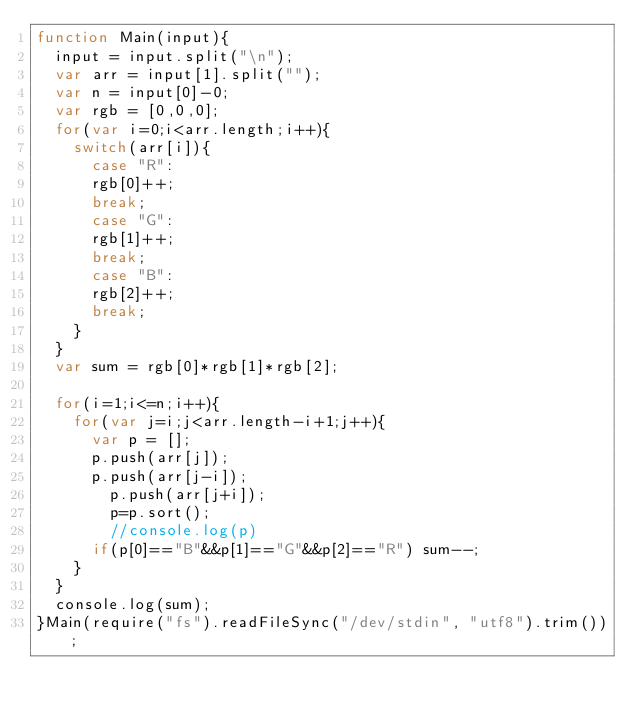Convert code to text. <code><loc_0><loc_0><loc_500><loc_500><_JavaScript_>function Main(input){
	input = input.split("\n");
	var arr = input[1].split("");
	var n = input[0]-0;
	var rgb = [0,0,0];
	for(var i=0;i<arr.length;i++){
		switch(arr[i]){
			case "R":
			rgb[0]++;
			break;
			case "G":
			rgb[1]++;
			break;
			case "B":
			rgb[2]++;
			break;
		}
	}
	var sum = rgb[0]*rgb[1]*rgb[2];

	for(i=1;i<=n;i++){
		for(var j=i;j<arr.length-i+1;j++){
			var p = [];
			p.push(arr[j]);
			p.push(arr[j-i]);
		    p.push(arr[j+i]);
		    p=p.sort();
		    //console.log(p)
			if(p[0]=="B"&&p[1]=="G"&&p[2]=="R") sum--;
		}
	}
	console.log(sum);
}Main(require("fs").readFileSync("/dev/stdin", "utf8").trim());</code> 